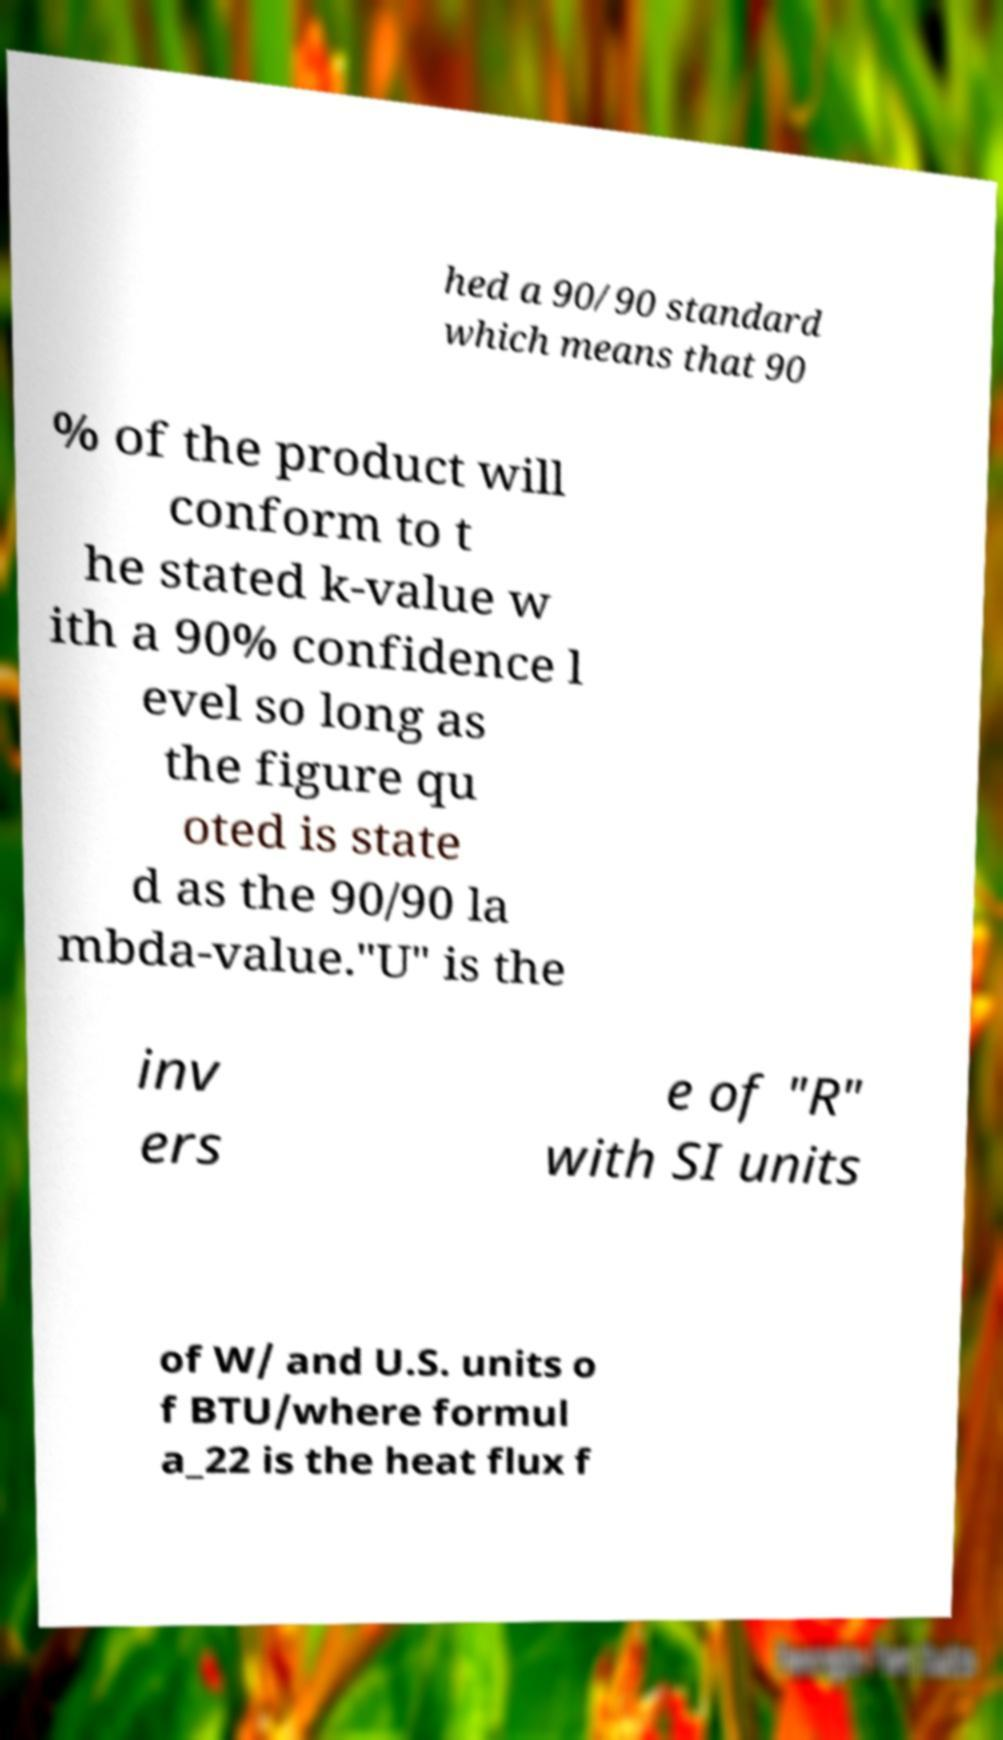Please identify and transcribe the text found in this image. hed a 90/90 standard which means that 90 % of the product will conform to t he stated k-value w ith a 90% confidence l evel so long as the figure qu oted is state d as the 90/90 la mbda-value."U" is the inv ers e of "R" with SI units of W/ and U.S. units o f BTU/where formul a_22 is the heat flux f 